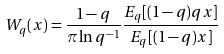<formula> <loc_0><loc_0><loc_500><loc_500>W _ { q } ( x ) = \frac { 1 - q } { \pi \ln q ^ { - 1 } } \frac { E _ { q } [ ( 1 - q ) q x ] } { E _ { q } [ ( 1 - q ) x ] }</formula> 